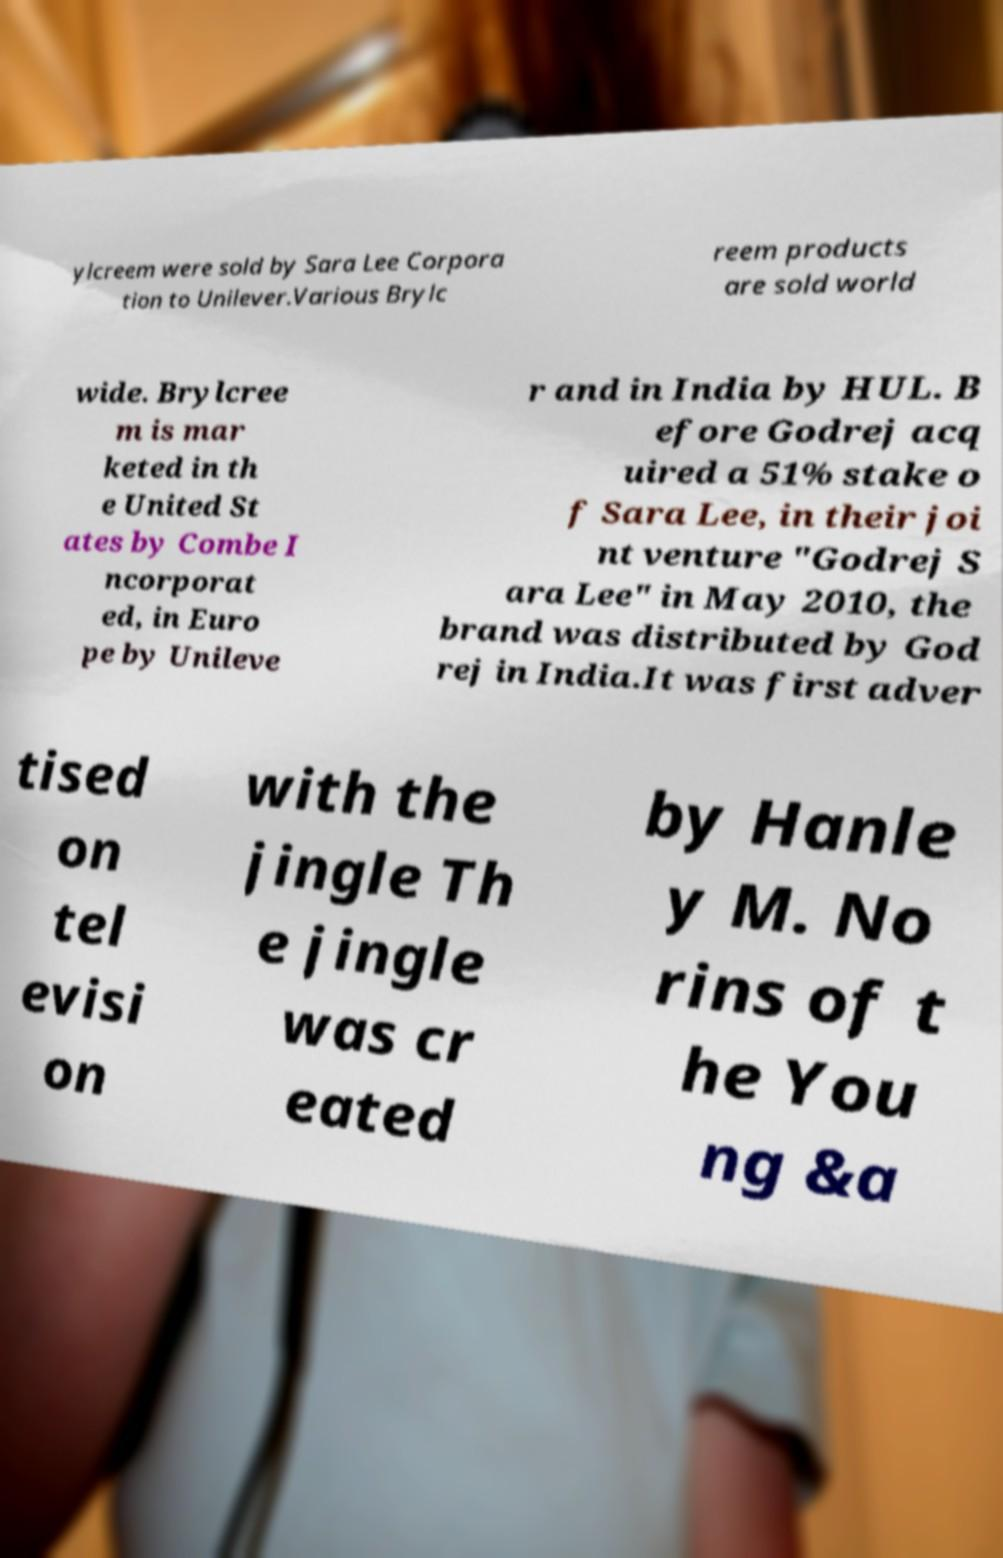Can you accurately transcribe the text from the provided image for me? ylcreem were sold by Sara Lee Corpora tion to Unilever.Various Brylc reem products are sold world wide. Brylcree m is mar keted in th e United St ates by Combe I ncorporat ed, in Euro pe by Unileve r and in India by HUL. B efore Godrej acq uired a 51% stake o f Sara Lee, in their joi nt venture "Godrej S ara Lee" in May 2010, the brand was distributed by God rej in India.It was first adver tised on tel evisi on with the jingle Th e jingle was cr eated by Hanle y M. No rins of t he You ng &a 